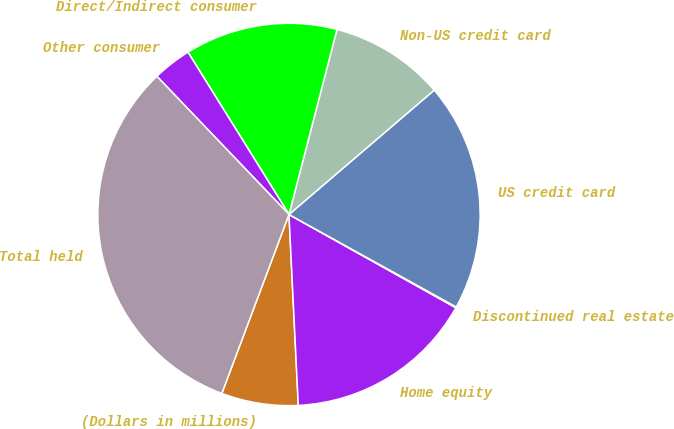Convert chart to OTSL. <chart><loc_0><loc_0><loc_500><loc_500><pie_chart><fcel>(Dollars in millions)<fcel>Home equity<fcel>Discontinued real estate<fcel>US credit card<fcel>Non-US credit card<fcel>Direct/Indirect consumer<fcel>Other consumer<fcel>Total held<nl><fcel>6.49%<fcel>16.11%<fcel>0.07%<fcel>19.31%<fcel>9.69%<fcel>12.9%<fcel>3.28%<fcel>32.14%<nl></chart> 